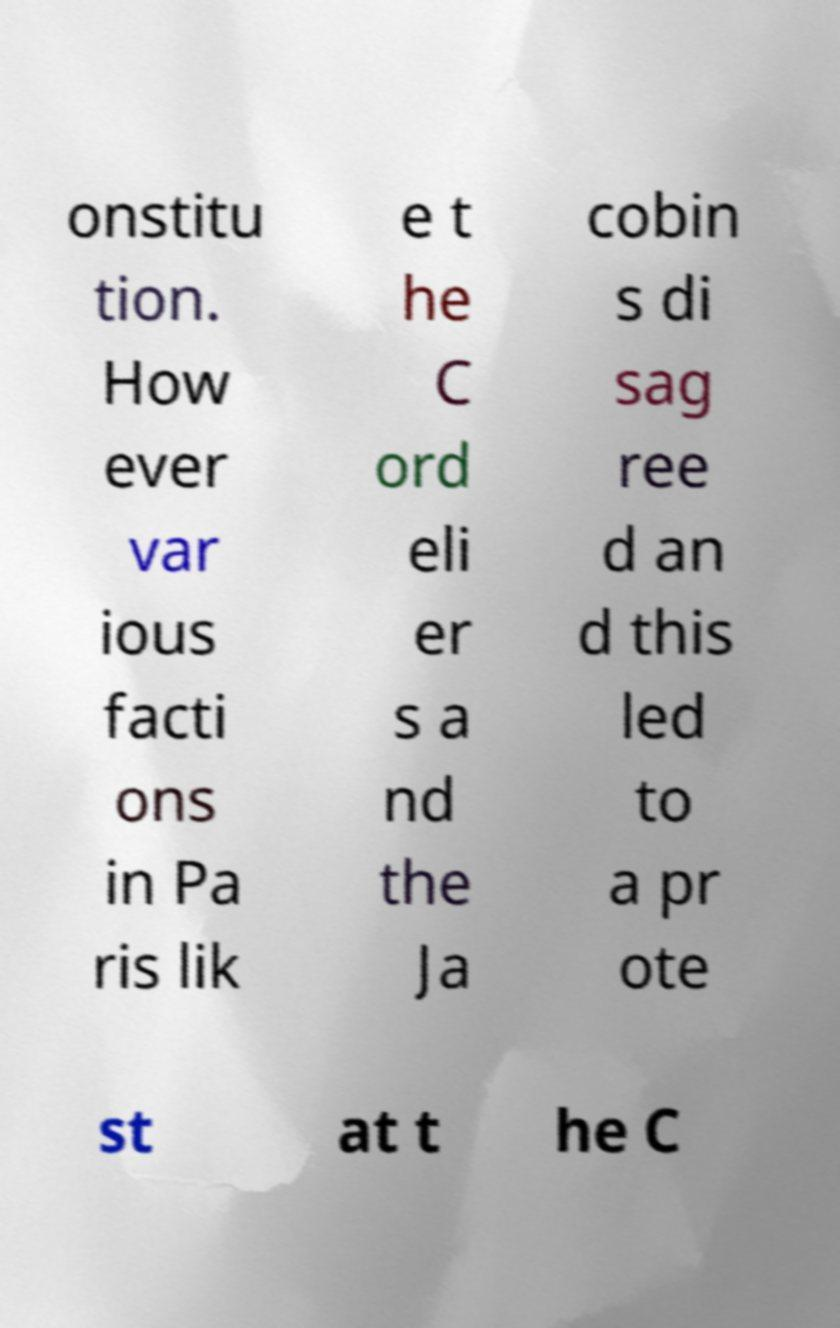Please identify and transcribe the text found in this image. onstitu tion. How ever var ious facti ons in Pa ris lik e t he C ord eli er s a nd the Ja cobin s di sag ree d an d this led to a pr ote st at t he C 